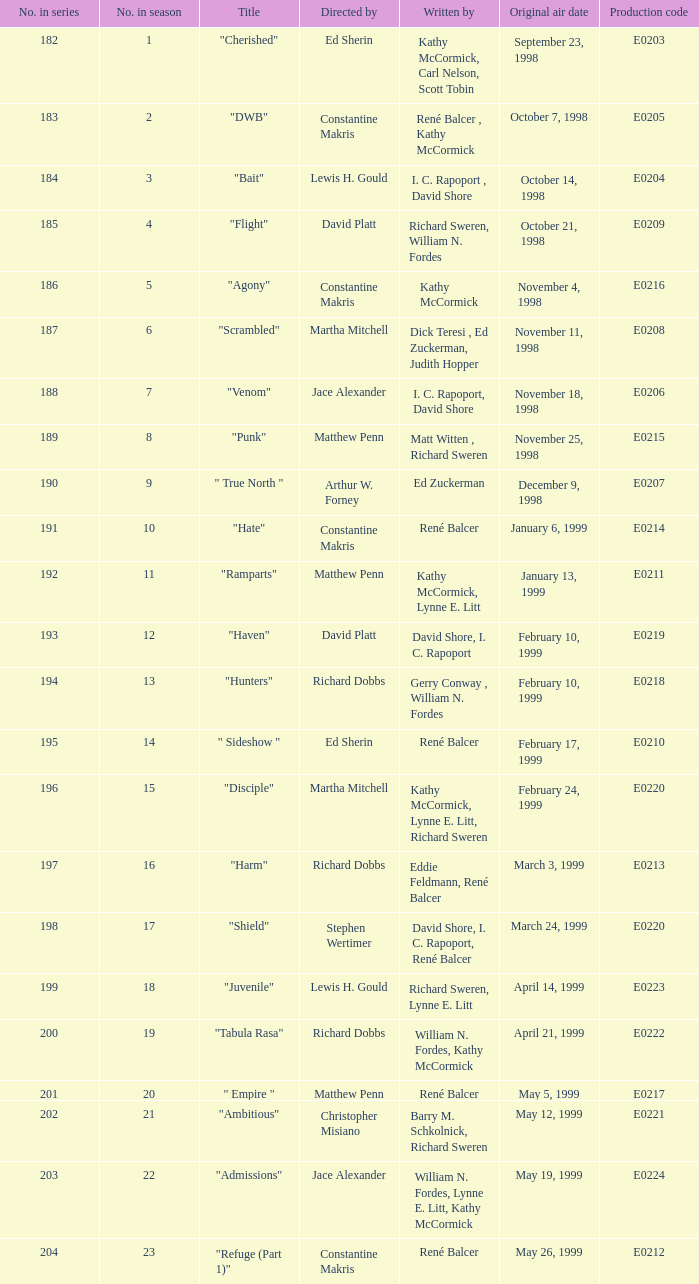Which season number includes an episode authored by matt witten and richard sweren? 8.0. 